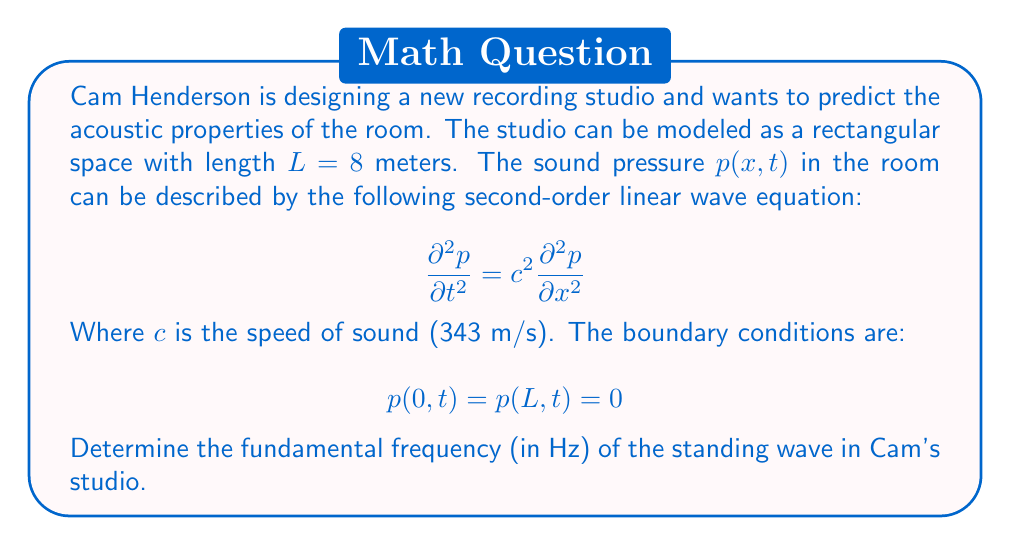Teach me how to tackle this problem. To solve this problem, we'll follow these steps:

1) The general solution for the wave equation with the given boundary conditions is:

   $$ p(x,t) = \sum_{n=1}^{\infty} A_n \sin(\frac{n\pi x}{L}) \cos(\frac{n\pi c t}{L}) $$

2) The fundamental frequency corresponds to n = 1. We're interested in the temporal part of the solution:

   $$ \cos(\frac{\pi c t}{L}) $$

3) The angular frequency $\omega$ is the coefficient of t:

   $$ \omega = \frac{\pi c}{L} $$

4) The frequency f is related to the angular frequency by:

   $$ f = \frac{\omega}{2\pi} $$

5) Substituting the known values:

   $$ f = \frac{c}{2L} = \frac{343}{2(8)} = \frac{343}{16} $$

6) Calculate the final result:

   $$ f = 21.4375 \text{ Hz} $$
Answer: The fundamental frequency of the standing wave in Cam Henderson's recording studio is approximately 21.44 Hz. 